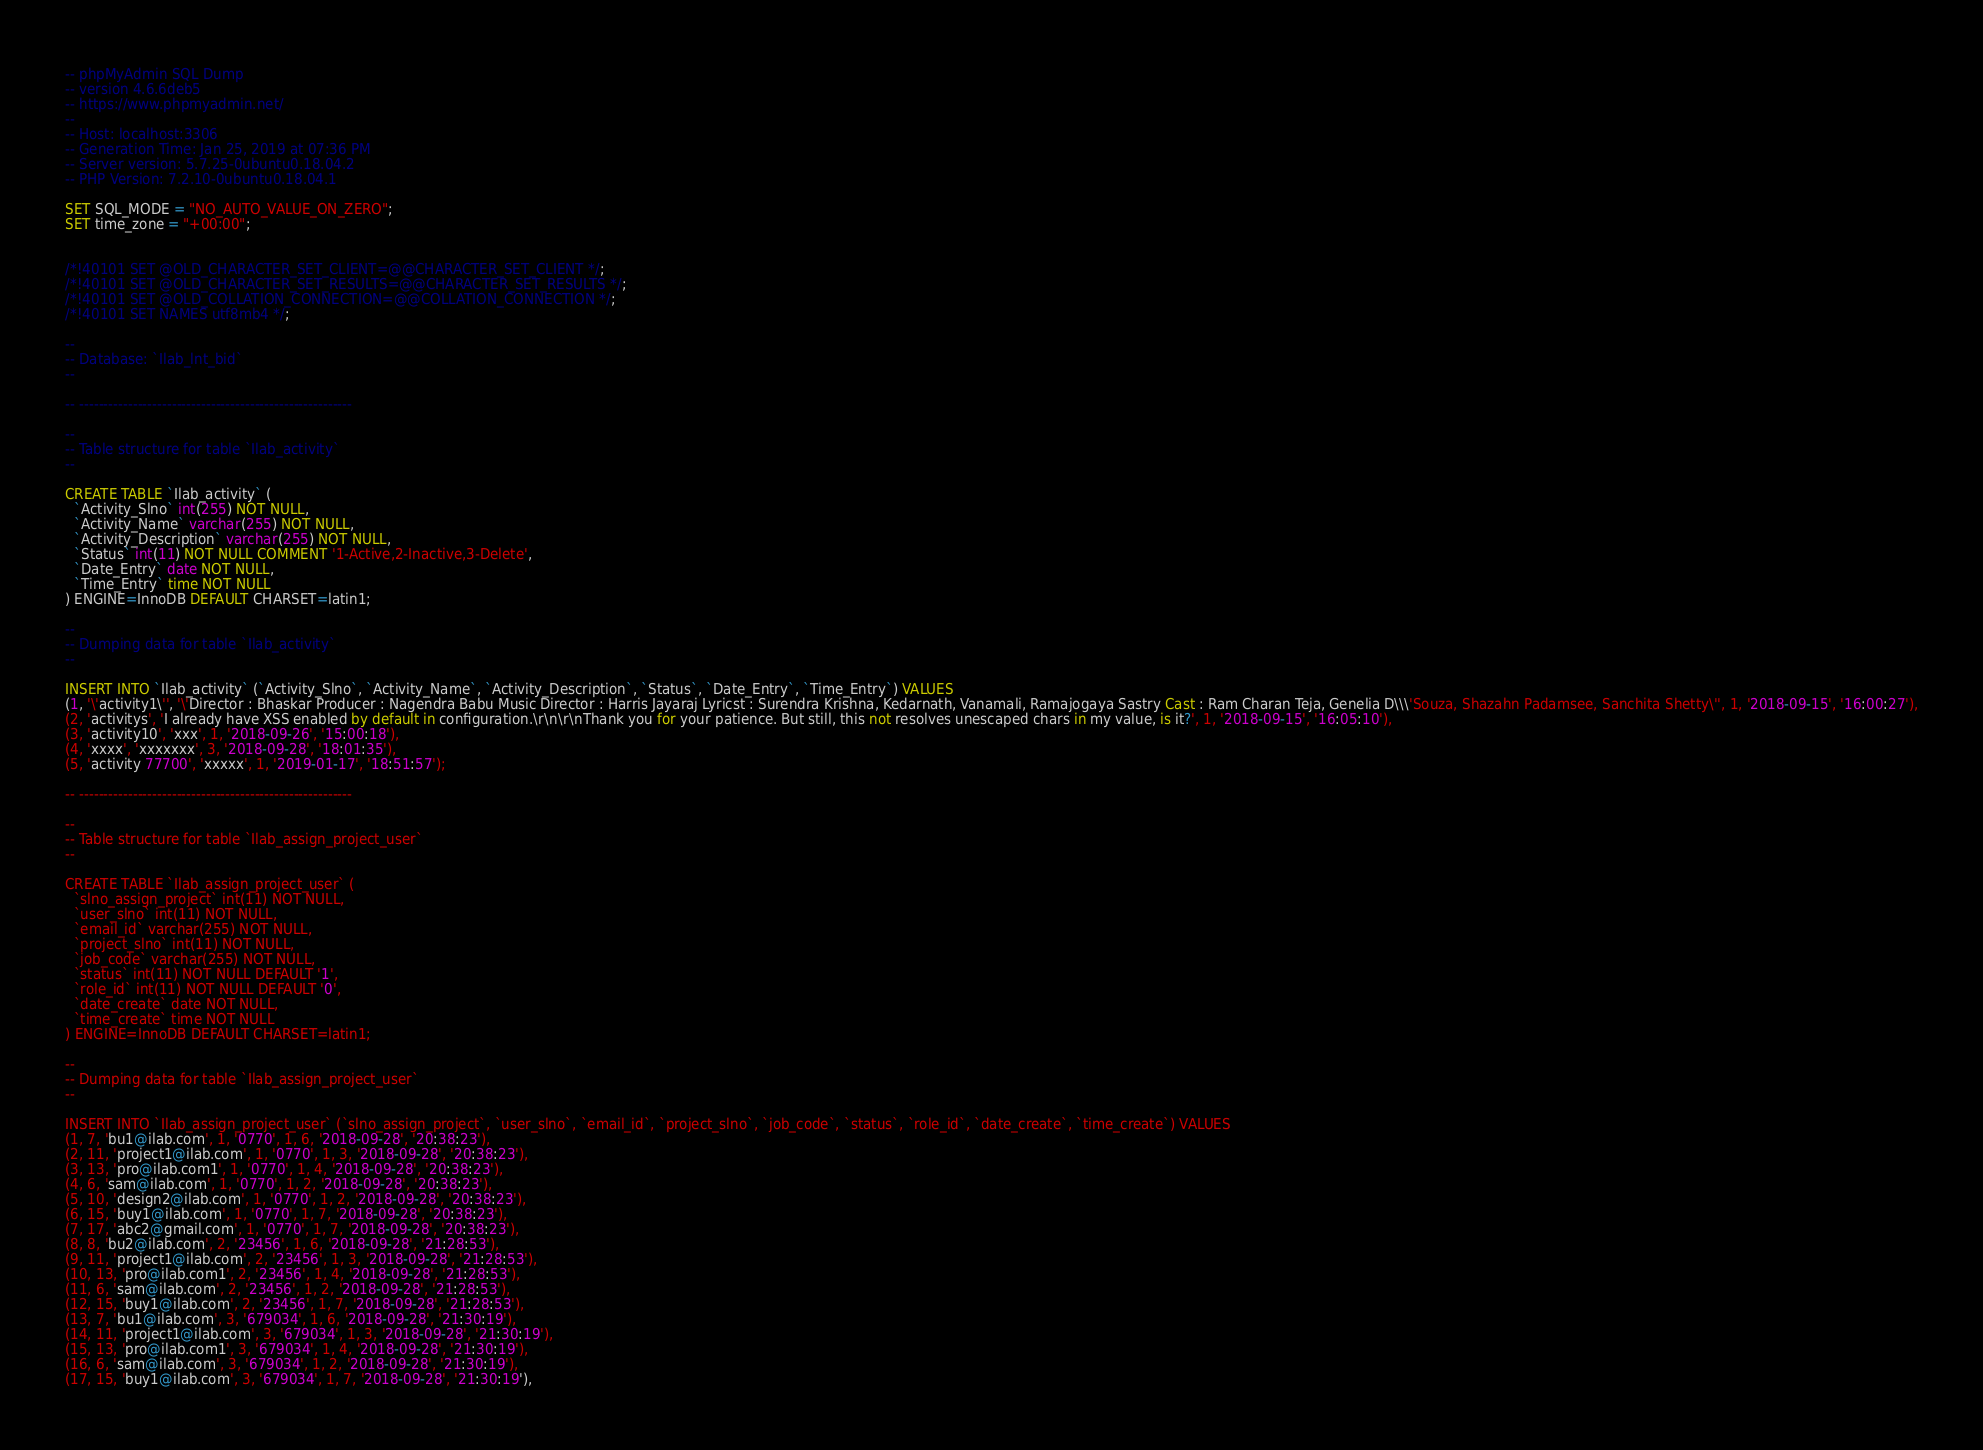Convert code to text. <code><loc_0><loc_0><loc_500><loc_500><_SQL_>-- phpMyAdmin SQL Dump
-- version 4.6.6deb5
-- https://www.phpmyadmin.net/
--
-- Host: localhost:3306
-- Generation Time: Jan 25, 2019 at 07:36 PM
-- Server version: 5.7.25-0ubuntu0.18.04.2
-- PHP Version: 7.2.10-0ubuntu0.18.04.1

SET SQL_MODE = "NO_AUTO_VALUE_ON_ZERO";
SET time_zone = "+00:00";


/*!40101 SET @OLD_CHARACTER_SET_CLIENT=@@CHARACTER_SET_CLIENT */;
/*!40101 SET @OLD_CHARACTER_SET_RESULTS=@@CHARACTER_SET_RESULTS */;
/*!40101 SET @OLD_COLLATION_CONNECTION=@@COLLATION_CONNECTION */;
/*!40101 SET NAMES utf8mb4 */;

--
-- Database: `Ilab_lnt_bid`
--

-- --------------------------------------------------------

--
-- Table structure for table `Ilab_activity`
--

CREATE TABLE `Ilab_activity` (
  `Activity_Slno` int(255) NOT NULL,
  `Activity_Name` varchar(255) NOT NULL,
  `Activity_Description` varchar(255) NOT NULL,
  `Status` int(11) NOT NULL COMMENT '1-Active,2-Inactive,3-Delete',
  `Date_Entry` date NOT NULL,
  `Time_Entry` time NOT NULL
) ENGINE=InnoDB DEFAULT CHARSET=latin1;

--
-- Dumping data for table `Ilab_activity`
--

INSERT INTO `Ilab_activity` (`Activity_Slno`, `Activity_Name`, `Activity_Description`, `Status`, `Date_Entry`, `Time_Entry`) VALUES
(1, '\'activity1\'', '\'Director : Bhaskar Producer : Nagendra Babu Music Director : Harris Jayaraj Lyricst : Surendra Krishna, Kedarnath, Vanamali, Ramajogaya Sastry Cast : Ram Charan Teja, Genelia D\\\'Souza, Shazahn Padamsee, Sanchita Shetty\'', 1, '2018-09-15', '16:00:27'),
(2, 'activitys', 'I already have XSS enabled by default in configuration.\r\n\r\nThank you for your patience. But still, this not resolves unescaped chars in my value, is it?', 1, '2018-09-15', '16:05:10'),
(3, 'activity10', 'xxx', 1, '2018-09-26', '15:00:18'),
(4, 'xxxx', 'xxxxxxx', 3, '2018-09-28', '18:01:35'),
(5, 'activity 77700', 'xxxxx', 1, '2019-01-17', '18:51:57');

-- --------------------------------------------------------

--
-- Table structure for table `Ilab_assign_project_user`
--

CREATE TABLE `Ilab_assign_project_user` (
  `slno_assign_project` int(11) NOT NULL,
  `user_slno` int(11) NOT NULL,
  `email_id` varchar(255) NOT NULL,
  `project_slno` int(11) NOT NULL,
  `job_code` varchar(255) NOT NULL,
  `status` int(11) NOT NULL DEFAULT '1',
  `role_id` int(11) NOT NULL DEFAULT '0',
  `date_create` date NOT NULL,
  `time_create` time NOT NULL
) ENGINE=InnoDB DEFAULT CHARSET=latin1;

--
-- Dumping data for table `Ilab_assign_project_user`
--

INSERT INTO `Ilab_assign_project_user` (`slno_assign_project`, `user_slno`, `email_id`, `project_slno`, `job_code`, `status`, `role_id`, `date_create`, `time_create`) VALUES
(1, 7, 'bu1@ilab.com', 1, '0770', 1, 6, '2018-09-28', '20:38:23'),
(2, 11, 'project1@ilab.com', 1, '0770', 1, 3, '2018-09-28', '20:38:23'),
(3, 13, 'pro@ilab.com1', 1, '0770', 1, 4, '2018-09-28', '20:38:23'),
(4, 6, 'sam@ilab.com', 1, '0770', 1, 2, '2018-09-28', '20:38:23'),
(5, 10, 'design2@ilab.com', 1, '0770', 1, 2, '2018-09-28', '20:38:23'),
(6, 15, 'buy1@ilab.com', 1, '0770', 1, 7, '2018-09-28', '20:38:23'),
(7, 17, 'abc2@gmail.com', 1, '0770', 1, 7, '2018-09-28', '20:38:23'),
(8, 8, 'bu2@ilab.com', 2, '23456', 1, 6, '2018-09-28', '21:28:53'),
(9, 11, 'project1@ilab.com', 2, '23456', 1, 3, '2018-09-28', '21:28:53'),
(10, 13, 'pro@ilab.com1', 2, '23456', 1, 4, '2018-09-28', '21:28:53'),
(11, 6, 'sam@ilab.com', 2, '23456', 1, 2, '2018-09-28', '21:28:53'),
(12, 15, 'buy1@ilab.com', 2, '23456', 1, 7, '2018-09-28', '21:28:53'),
(13, 7, 'bu1@ilab.com', 3, '679034', 1, 6, '2018-09-28', '21:30:19'),
(14, 11, 'project1@ilab.com', 3, '679034', 1, 3, '2018-09-28', '21:30:19'),
(15, 13, 'pro@ilab.com1', 3, '679034', 1, 4, '2018-09-28', '21:30:19'),
(16, 6, 'sam@ilab.com', 3, '679034', 1, 2, '2018-09-28', '21:30:19'),
(17, 15, 'buy1@ilab.com', 3, '679034', 1, 7, '2018-09-28', '21:30:19'),</code> 